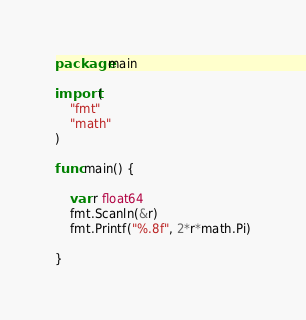<code> <loc_0><loc_0><loc_500><loc_500><_Go_>package main

import (
	"fmt"
	"math"
)

func main() {

	var r float64
	fmt.Scanln(&r)
	fmt.Printf("%.8f", 2*r*math.Pi)

}

</code> 